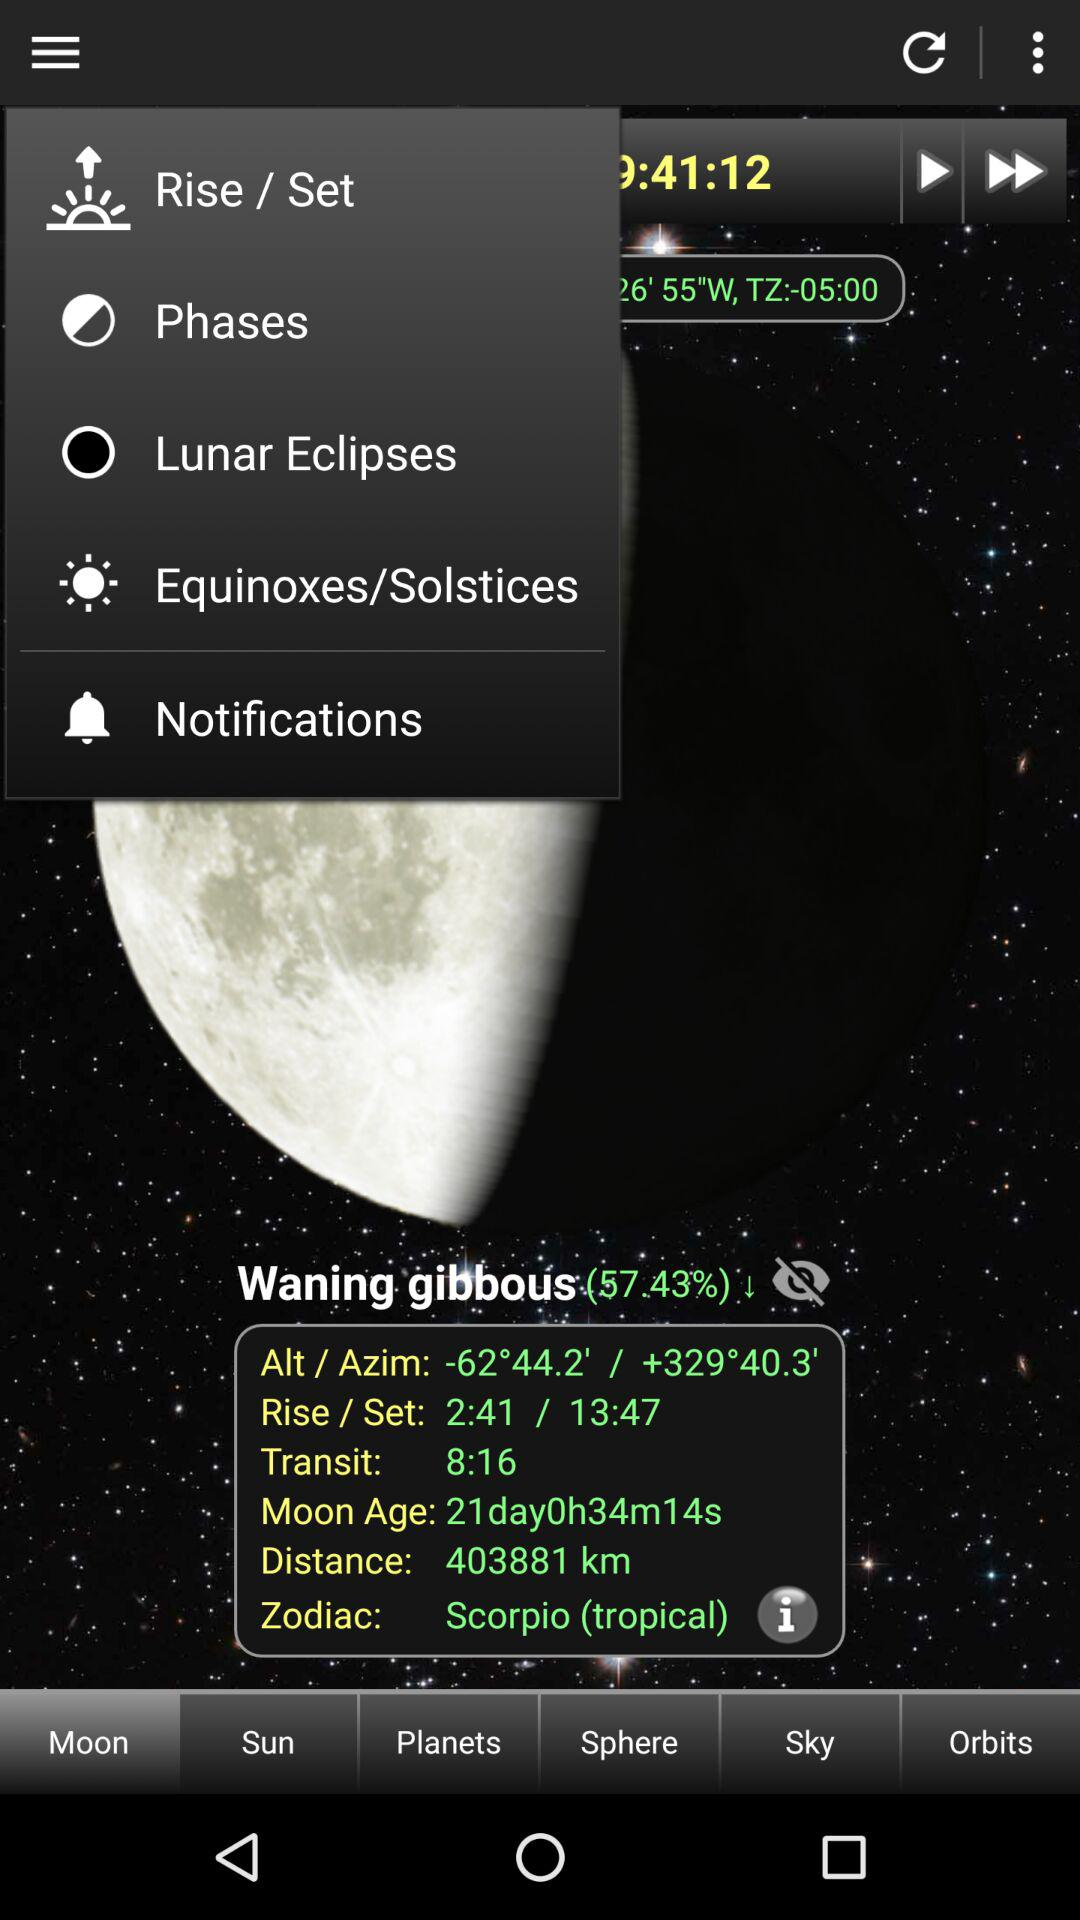What is the percentage of waning gibbous? The percentage of waning gibbous is 57.43. 